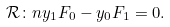Convert formula to latex. <formula><loc_0><loc_0><loc_500><loc_500>\mathcal { R } \colon n y _ { 1 } F _ { 0 } - y _ { 0 } F _ { 1 } = 0 .</formula> 